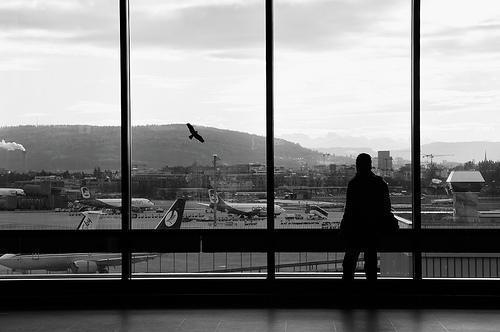How many people are by the window?
Give a very brief answer. 1. 